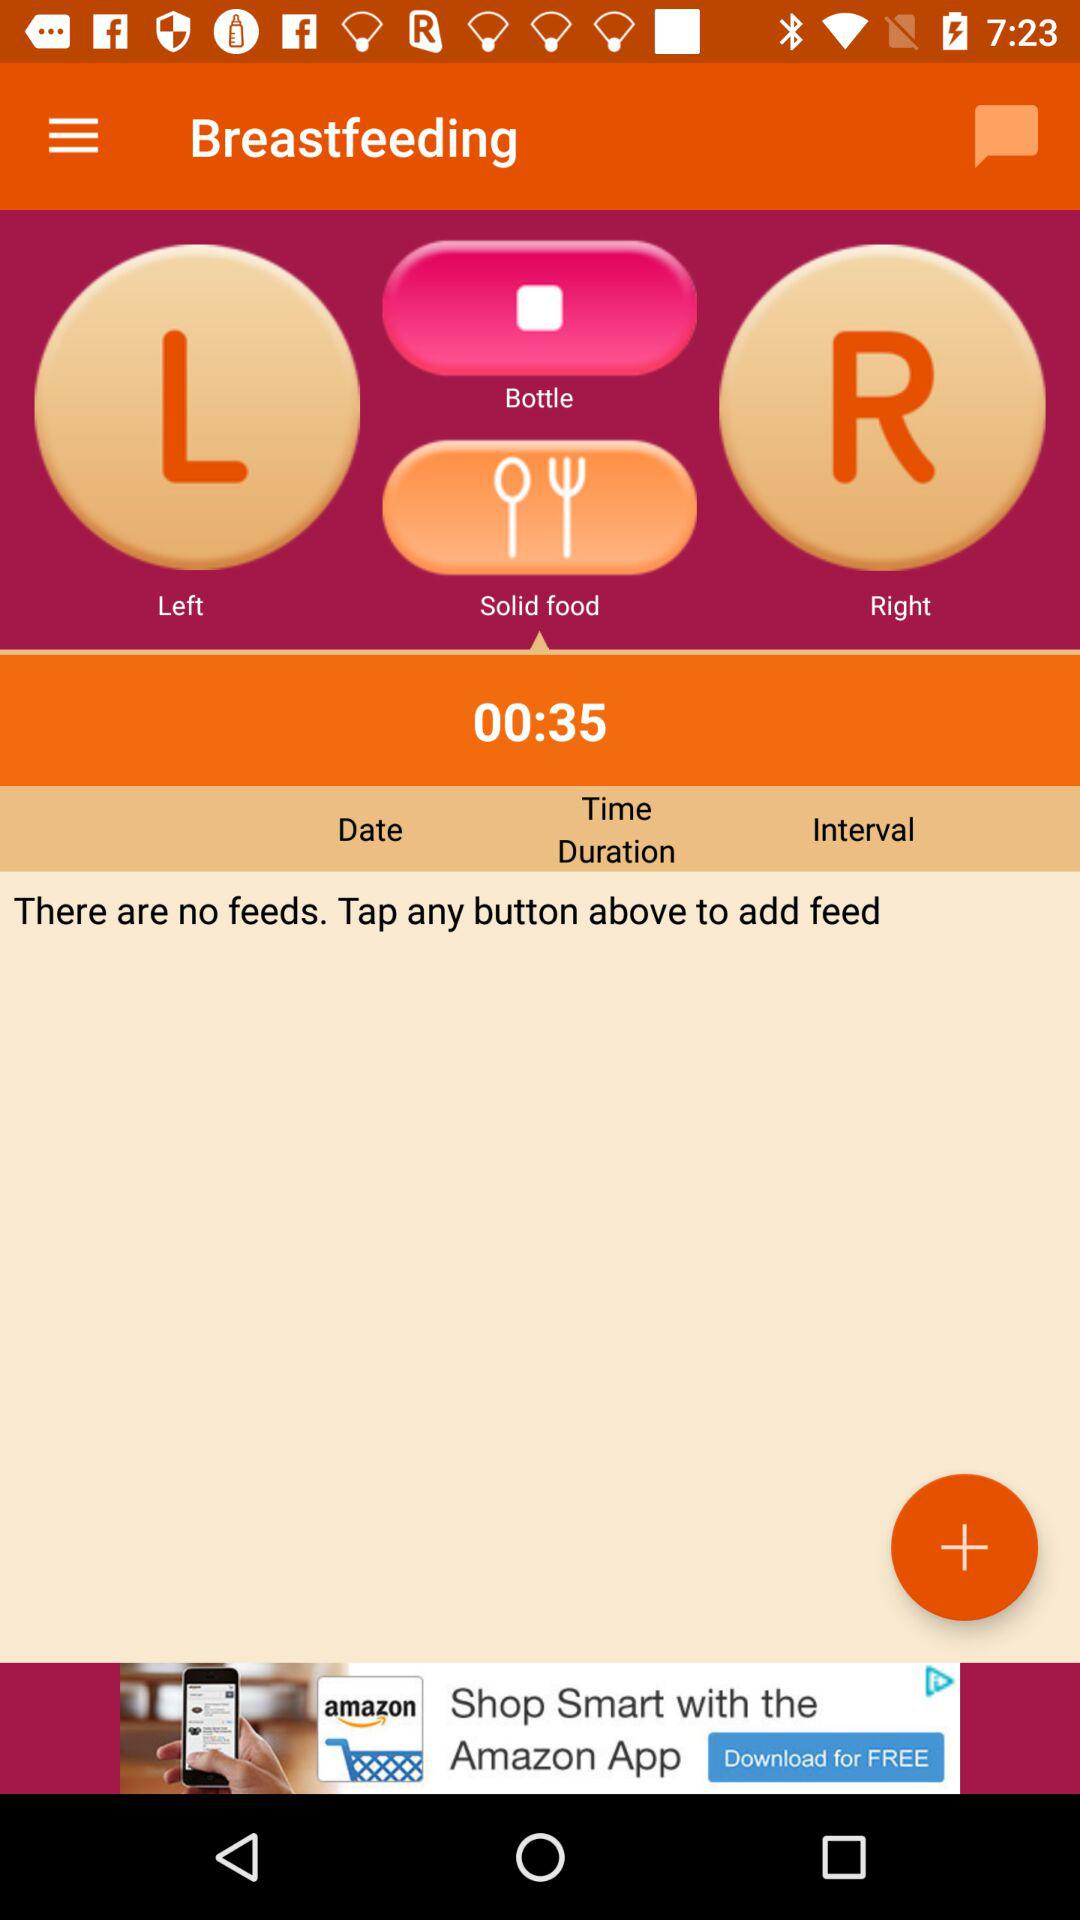What should be done to add the feed? To add the feed, any button above should be tapped. 